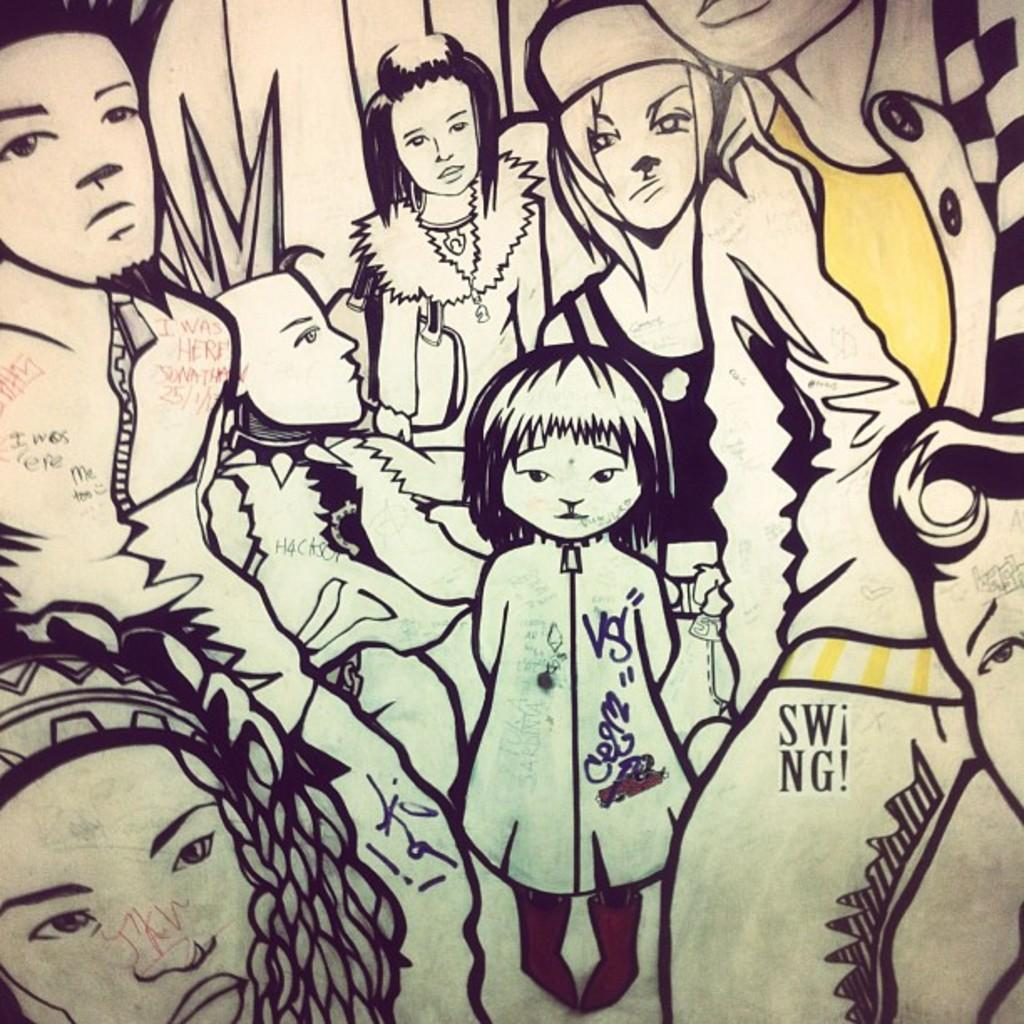What is the color scheme of the image? The image is black and white. What is the main subject of the image? The image contains a depiction of a picture. What type of oil can be seen in the image? There is no oil present in the image. Is there a pocket visible in the image? There is no pocket visible in the image. 